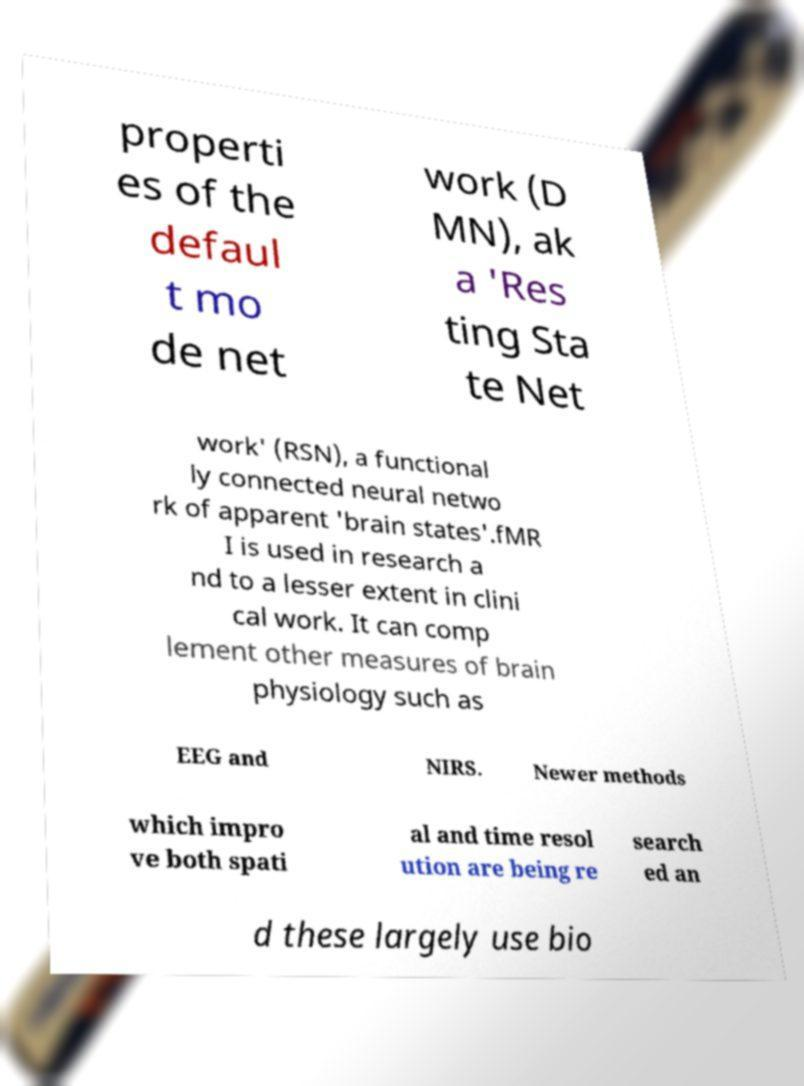There's text embedded in this image that I need extracted. Can you transcribe it verbatim? properti es of the defaul t mo de net work (D MN), ak a 'Res ting Sta te Net work' (RSN), a functional ly connected neural netwo rk of apparent 'brain states'.fMR I is used in research a nd to a lesser extent in clini cal work. It can comp lement other measures of brain physiology such as EEG and NIRS. Newer methods which impro ve both spati al and time resol ution are being re search ed an d these largely use bio 